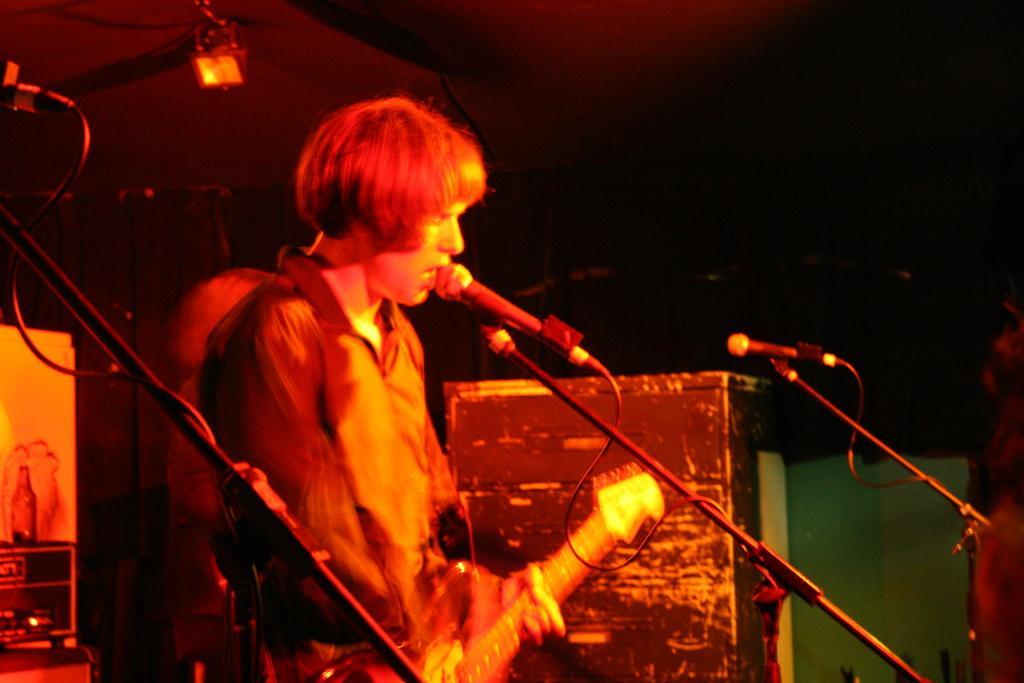Can you describe this image briefly? In this picture we can see a man is playing guitar in front of microphone, in the background we can see lights. 